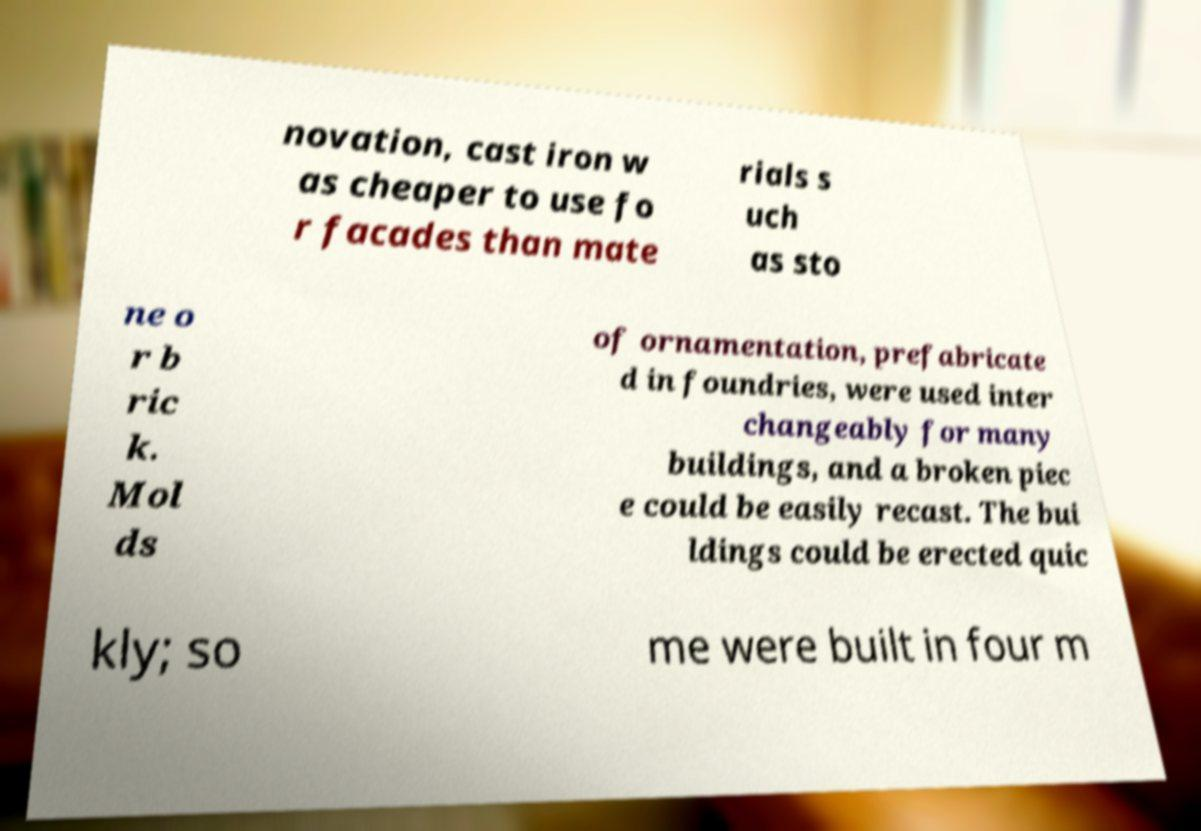For documentation purposes, I need the text within this image transcribed. Could you provide that? novation, cast iron w as cheaper to use fo r facades than mate rials s uch as sto ne o r b ric k. Mol ds of ornamentation, prefabricate d in foundries, were used inter changeably for many buildings, and a broken piec e could be easily recast. The bui ldings could be erected quic kly; so me were built in four m 